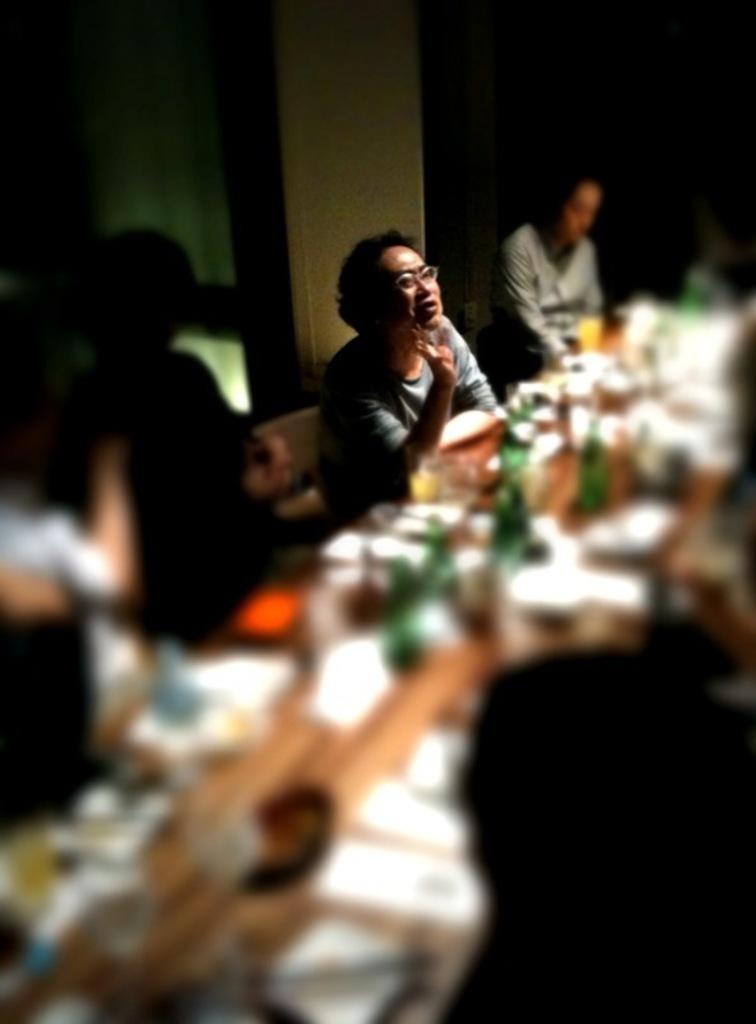What is the main piece of furniture in the image? There is a table in the image. What is on the table in the image? The table has many items on it. Can you describe the people in the image? There are people in the image, including a man who is sitting. What is behind the man in the image? There is a pillar behind the man. What type of jelly is being used as a decoration on the table in the image? There is no jelly present in the image; it is a table with many items on it. Where is the park located in the image? There is no park present in the image; it is an indoor setting with a table, people, and a pillar. 